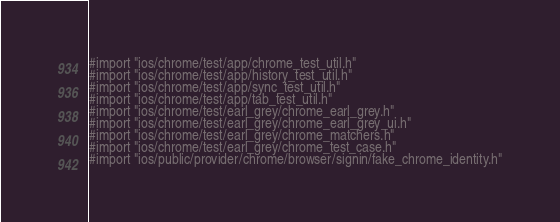Convert code to text. <code><loc_0><loc_0><loc_500><loc_500><_ObjectiveC_>#import "ios/chrome/test/app/chrome_test_util.h"
#import "ios/chrome/test/app/history_test_util.h"
#import "ios/chrome/test/app/sync_test_util.h"
#import "ios/chrome/test/app/tab_test_util.h"
#import "ios/chrome/test/earl_grey/chrome_earl_grey.h"
#import "ios/chrome/test/earl_grey/chrome_earl_grey_ui.h"
#import "ios/chrome/test/earl_grey/chrome_matchers.h"
#import "ios/chrome/test/earl_grey/chrome_test_case.h"
#import "ios/public/provider/chrome/browser/signin/fake_chrome_identity.h"</code> 